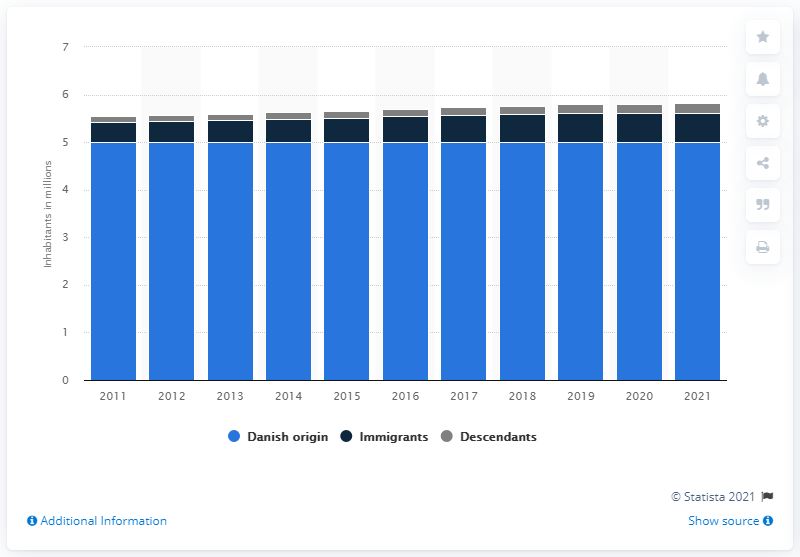Mention a couple of crucial points in this snapshot. There were approximately 0.2 descendants in Denmark in 2021. In 2021, it is estimated that approximately 0.62% of the population of Denmark had Danish origin. In 2021, there were approximately 0.62 million immigrants in Denmark. 